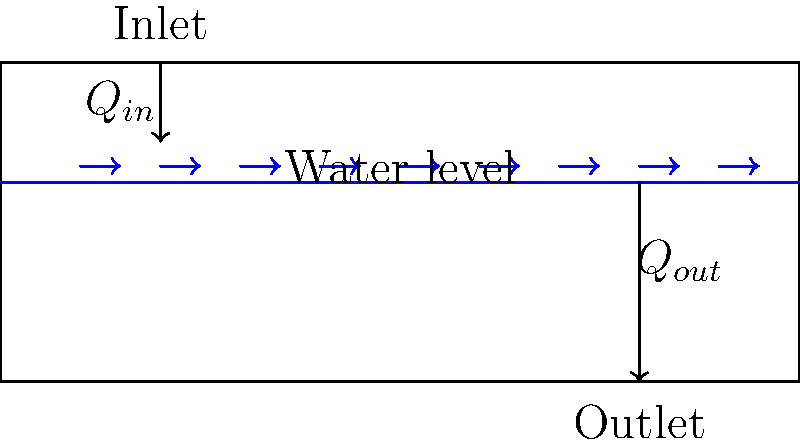In the luxurious hydrotherapy bathtub shown, the water flow rate at the inlet is $Q_{in} = 0.05 \, \text{m}^3/\text{s}$. If the desired constant water level is to be maintained, what should be the flow rate at the outlet ($Q_{out}$) in $\text{m}^3/\text{s}$? To maintain a constant water level in the bathtub, we need to apply the principle of conservation of mass for incompressible fluids. This principle states that the rate of mass entering a system must equal the rate of mass leaving the system for the water level to remain constant.

Steps to solve:

1. Recognize that for incompressible fluids, the conservation of mass simplifies to conservation of volume.

2. Set up the equation for conservation of volume:
   $$Q_{in} = Q_{out}$$

3. We are given that $Q_{in} = 0.05 \, \text{m}^3/\text{s}$

4. Therefore, to maintain a constant water level:
   $$Q_{out} = Q_{in} = 0.05 \, \text{m}^3/\text{s}$$

Thus, the outlet flow rate should be equal to the inlet flow rate to maintain the desired constant water level in the hydrotherapy bathtub.
Answer: $0.05 \, \text{m}^3/\text{s}$ 